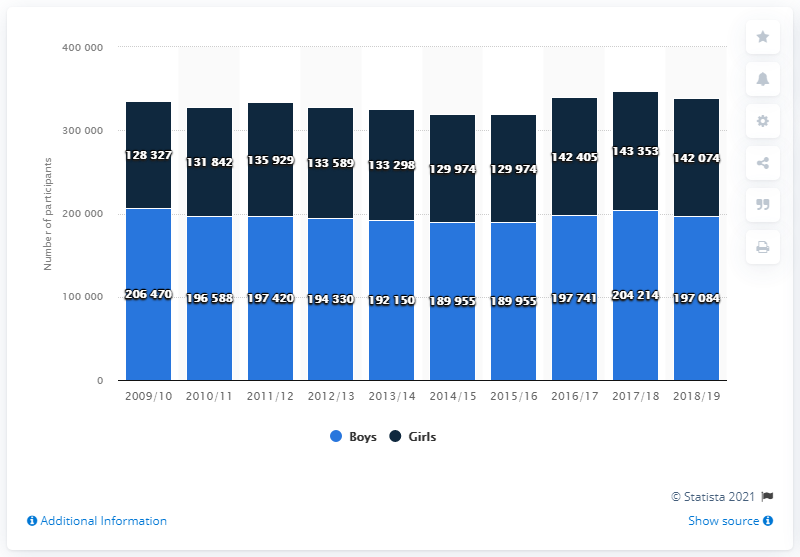Give some essential details in this illustration. In the 2018/2019 school year, a total of 197,084 boys participated in high school sports. 